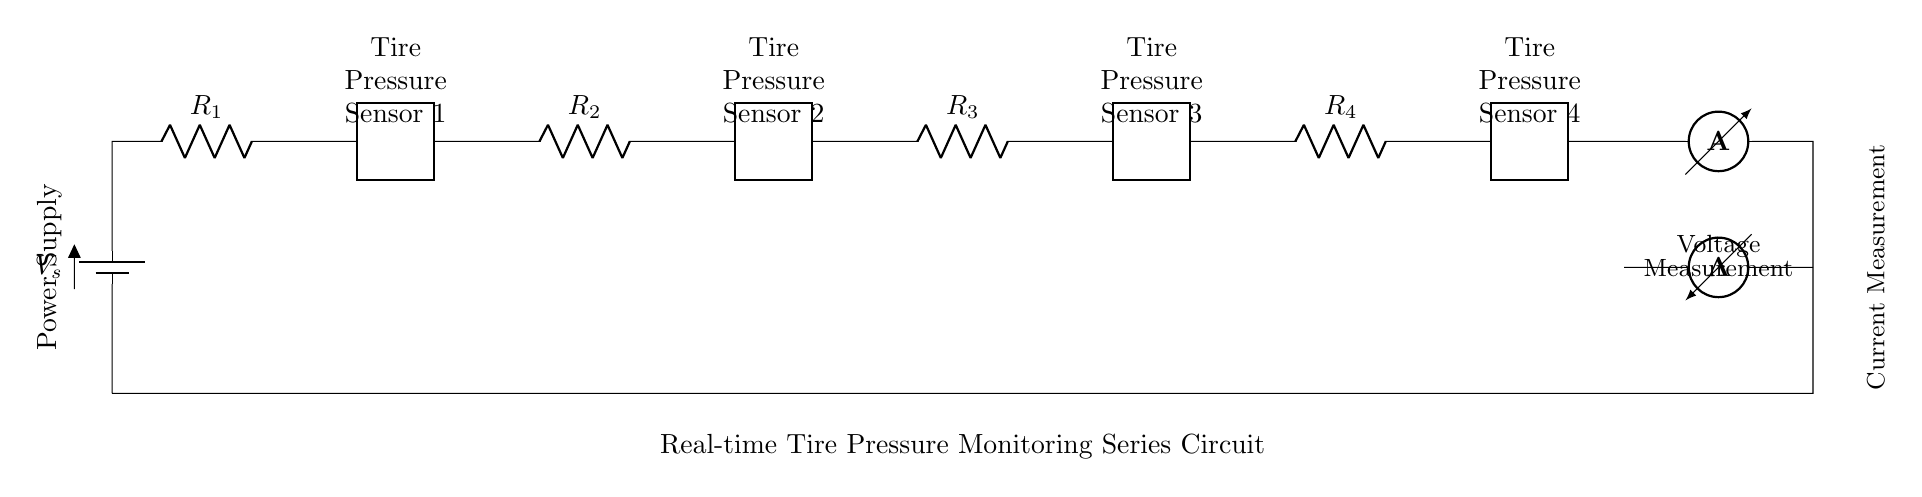What is the type of the first component in the circuit? The first component in the circuit is a battery. It provides the voltage source for the entire circuit.
Answer: battery How many tire pressure sensors are included in the circuit? The circuit includes four tire pressure sensors, as indicated by the labels for each sensor in the diagram.
Answer: four What does the ammeter measure in this circuit? The ammeter measures the current flowing through the circuit. It is connected in series, allowing it to read the total current that passes through all connected components.
Answer: current If the resistance values are equal, what will happen to the current through each sensor? If the resistance values are equal, the total resistance will be shared equally among all components in the series, resulting in equal currents through each sensor as dictated by Ohm's law.
Answer: equal What is the voltage measurement point in this circuit? The voltage measurement point is indicated at the terminals of the voltmeter, specifically between the last sensor and the ammeter. This shows the voltage across the last sensor.
Answer: last sensor What is the configuration of the tire pressure sensors in this circuit? The tire pressure sensors are connected in series, meaning the output of one sensor feeds into the next, which affects the overall circuit characteristics.
Answer: series 